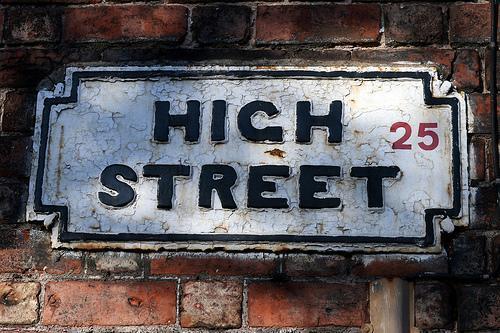How many different colors is the sign painted?
Give a very brief answer. 3. How many people appear in this picture?
Give a very brief answer. 0. 